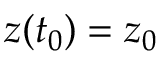Convert formula to latex. <formula><loc_0><loc_0><loc_500><loc_500>z ( t _ { 0 } ) = z _ { 0 }</formula> 